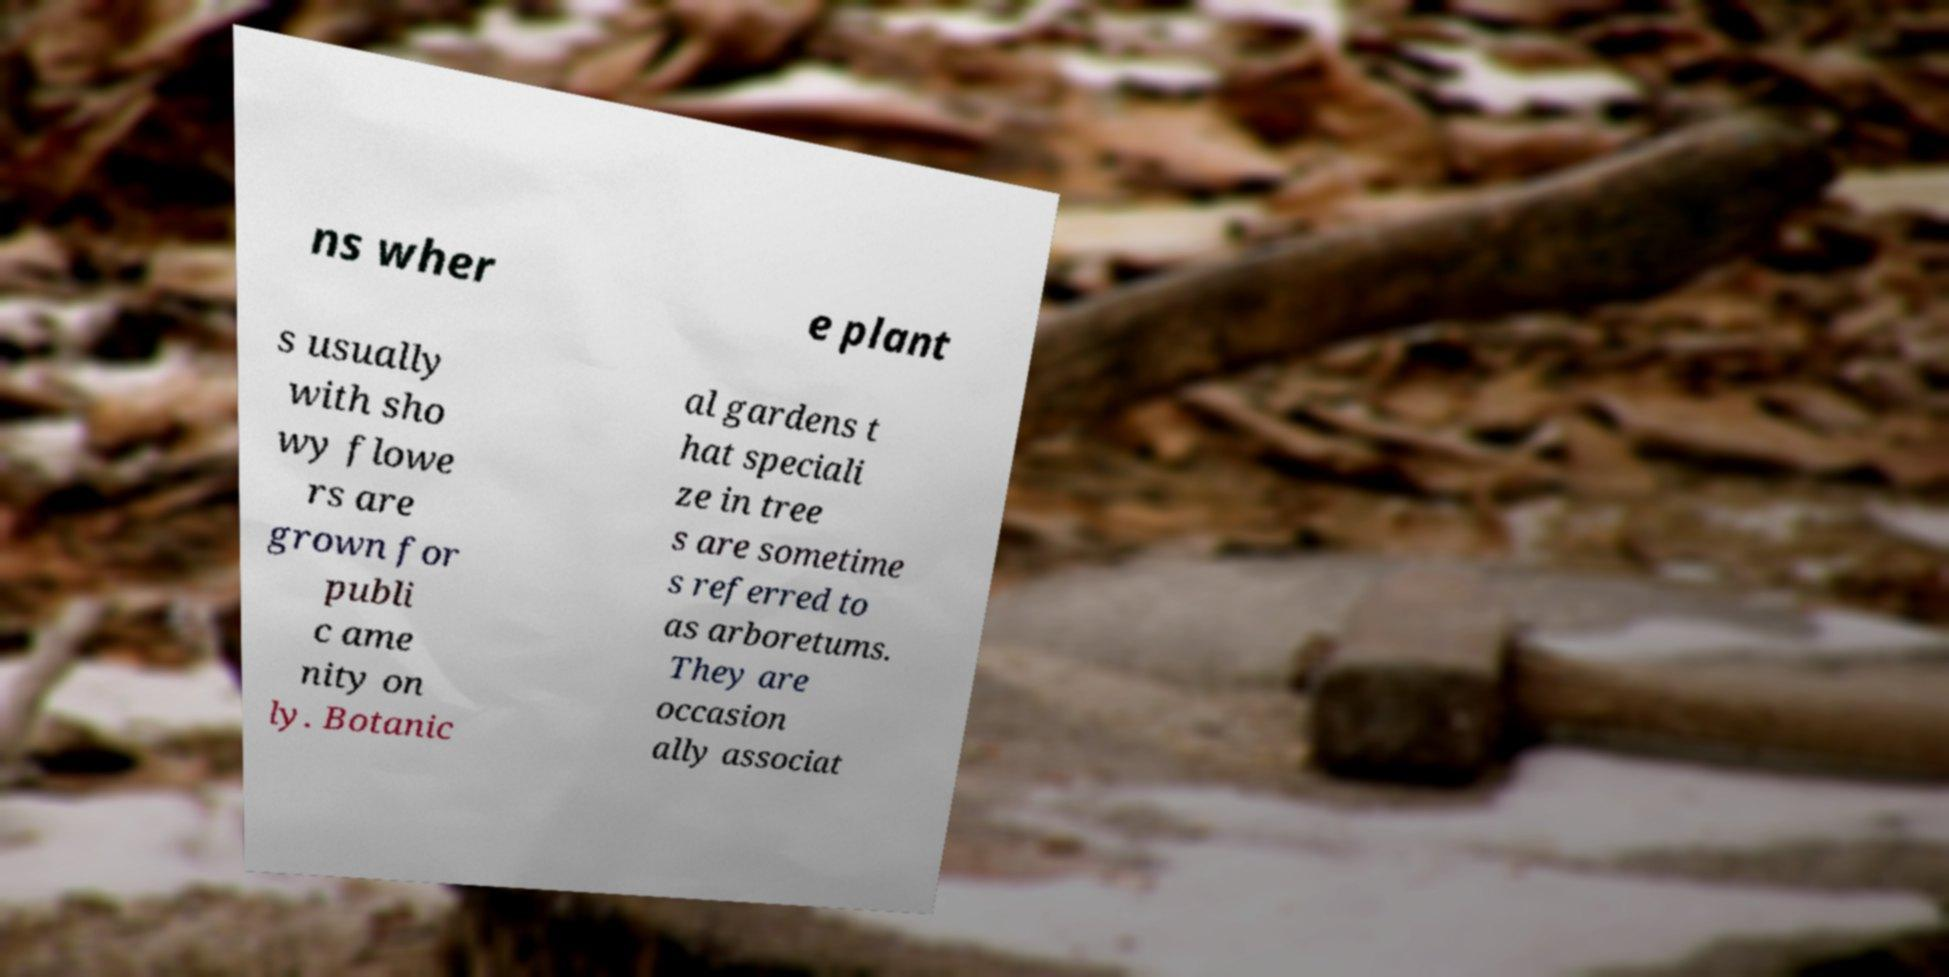What messages or text are displayed in this image? I need them in a readable, typed format. ns wher e plant s usually with sho wy flowe rs are grown for publi c ame nity on ly. Botanic al gardens t hat speciali ze in tree s are sometime s referred to as arboretums. They are occasion ally associat 